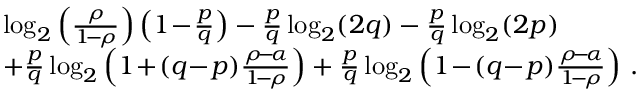<formula> <loc_0><loc_0><loc_500><loc_500>\begin{array} { r l } & { \log _ { 2 } \left ( \frac { \rho } { 1 \, - \, \rho } \right ) \left ( 1 \, - \, \frac { p } { q } \right ) - \frac { p } { q } \log _ { 2 } ( 2 q ) - \frac { p } { q } \log _ { 2 } ( 2 p ) } \\ & { + \frac { p } { q } \log _ { 2 } \left ( 1 \, + \, ( q \, - \, p ) \frac { \rho \, - \, \alpha } { 1 \, - \, \rho } \right ) + \frac { p } { q } \log _ { 2 } \left ( 1 \, - \, ( q \, - \, p ) \frac { \rho \, - \, \alpha } { 1 \, - \, \rho } \right ) \, . } \end{array}</formula> 